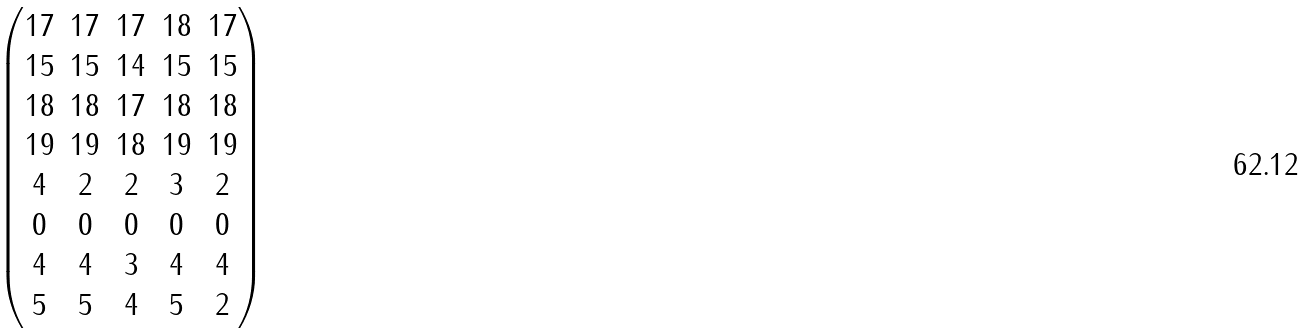Convert formula to latex. <formula><loc_0><loc_0><loc_500><loc_500>\begin{pmatrix} 1 7 & 1 7 & 1 7 & 1 8 & 1 7 \\ 1 5 & 1 5 & 1 4 & 1 5 & 1 5 \\ 1 8 & 1 8 & 1 7 & 1 8 & 1 8 \\ 1 9 & 1 9 & 1 8 & 1 9 & 1 9 \\ 4 & 2 & 2 & 3 & 2 \\ 0 & 0 & 0 & 0 & 0 \\ 4 & 4 & 3 & 4 & 4 \\ 5 & 5 & 4 & 5 & 2 \end{pmatrix}</formula> 